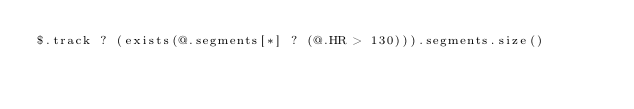Convert code to text. <code><loc_0><loc_0><loc_500><loc_500><_SQL_>$.track ? (exists(@.segments[*] ? (@.HR > 130))).segments.size()
</code> 